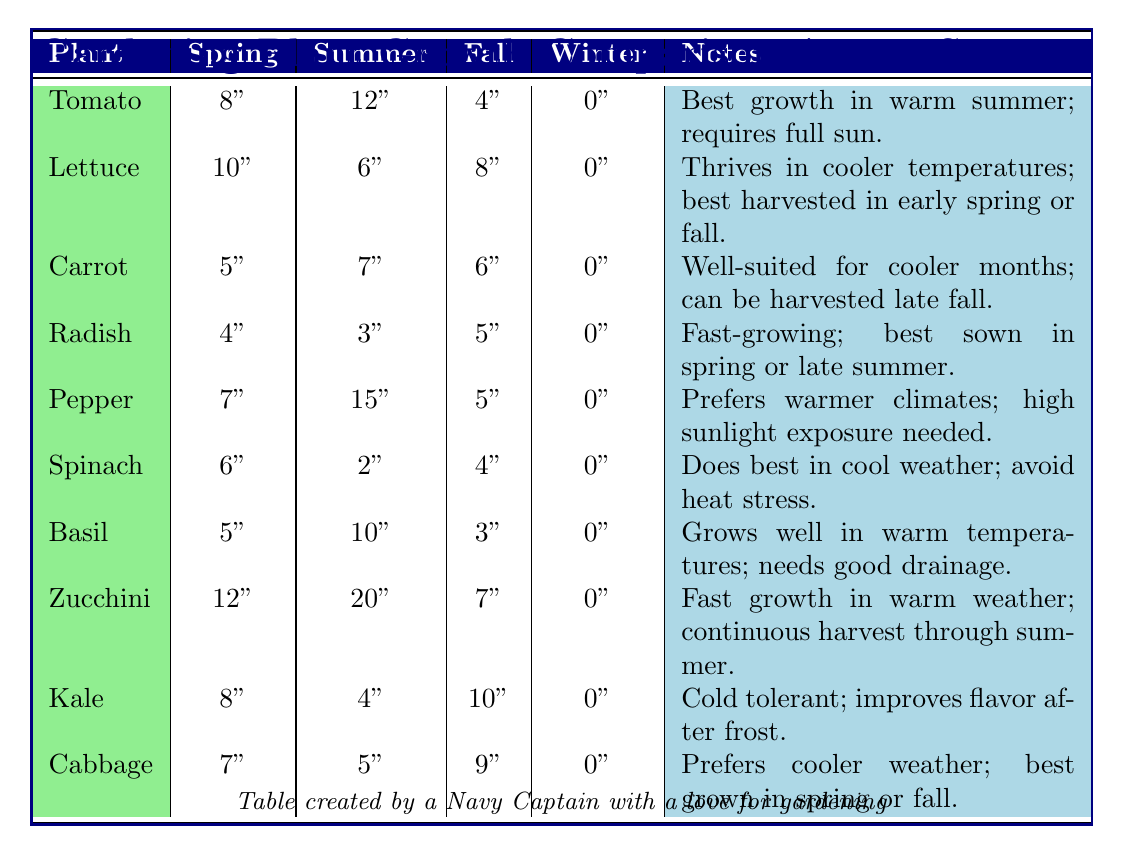What is the highest growth recorded for Tomato in a season? The table indicates that Tomato has its highest growth in summer, which is 12 inches.
Answer: 12 inches Which plant shows the most growth during the summer? The table shows that Pepper has the highest summer growth at 15 inches, which is more than other plants listed.
Answer: Pepper What is the total growth of Zucchini across all seasons? Adding Zucchini's growth: 12 (spring) + 20 (summer) + 7 (fall) + 0 (winter) = 39 inches.
Answer: 39 inches Does Basil grow better in spring or fall? Basil has 5 inches of growth in spring and only 3 inches in fall, indicating better growth in spring.
Answer: Yes What is the average growth of Kale in the fall and winter? Kale has 10 inches of growth in fall and 0 in winter, so the average is (10 + 0)/2 = 5 inches.
Answer: 5 inches Which plant grows the least in summer? According to the table, Spinach grows the least in summer with only 2 inches compared to other plants.
Answer: Spinach What is the difference in growth between Lettuce in spring and fall? Lettuce grows 10 inches in spring and 8 inches in fall, so the difference is 10 - 8 = 2 inches.
Answer: 2 inches Which plant has no growth in winter? All listed plants have 0 growth in winter according to the table.
Answer: All plants How many more inches does Zucchini grow in summer compared to Winter? Zucchini grows 20 inches in summer and 0 in winter, giving a difference of 20 - 0 = 20 inches.
Answer: 20 inches If you were to rank the plants by their spring growth, which plant would be fifth? Ranking by spring growth: 1) Lettuce (10) 2) Tomato (8) 3) Kale (8) 4) Pepper (7) 5) Cabbage (7). Hence, Cabbage is fifth.
Answer: Cabbage 